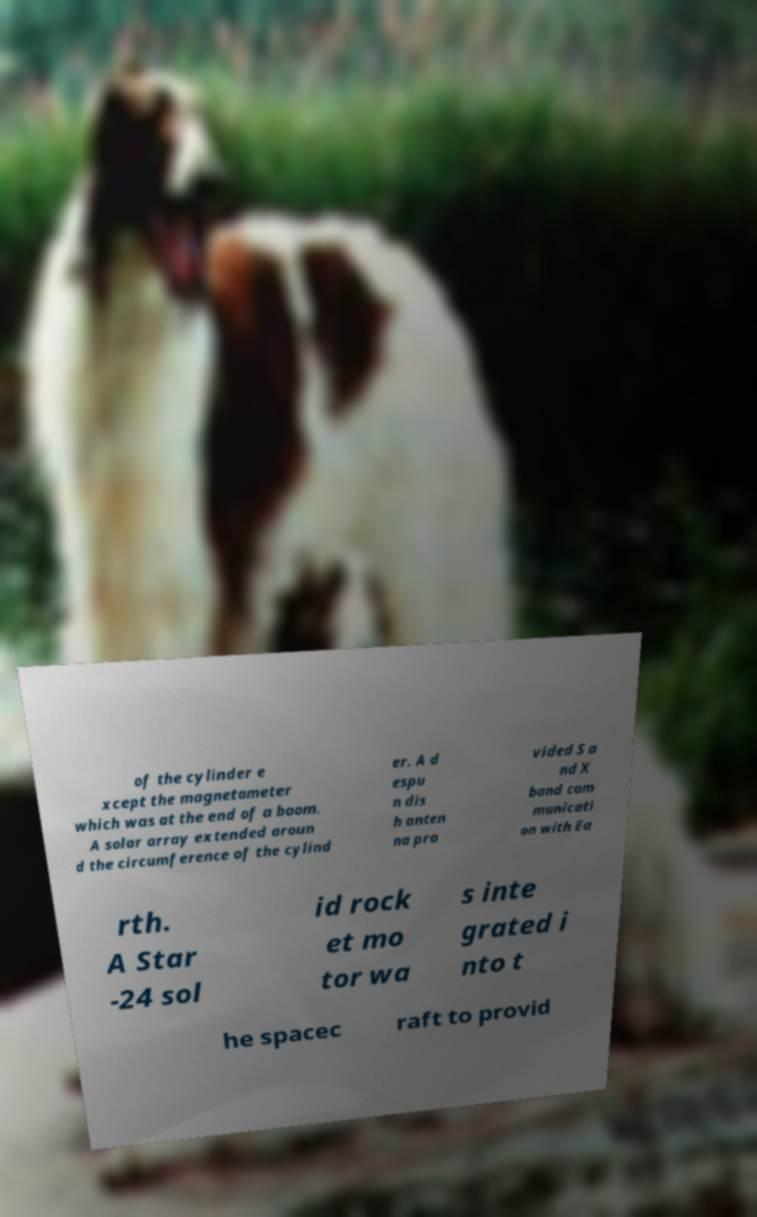Can you read and provide the text displayed in the image?This photo seems to have some interesting text. Can you extract and type it out for me? of the cylinder e xcept the magnetometer which was at the end of a boom. A solar array extended aroun d the circumference of the cylind er. A d espu n dis h anten na pro vided S a nd X band com municati on with Ea rth. A Star -24 sol id rock et mo tor wa s inte grated i nto t he spacec raft to provid 